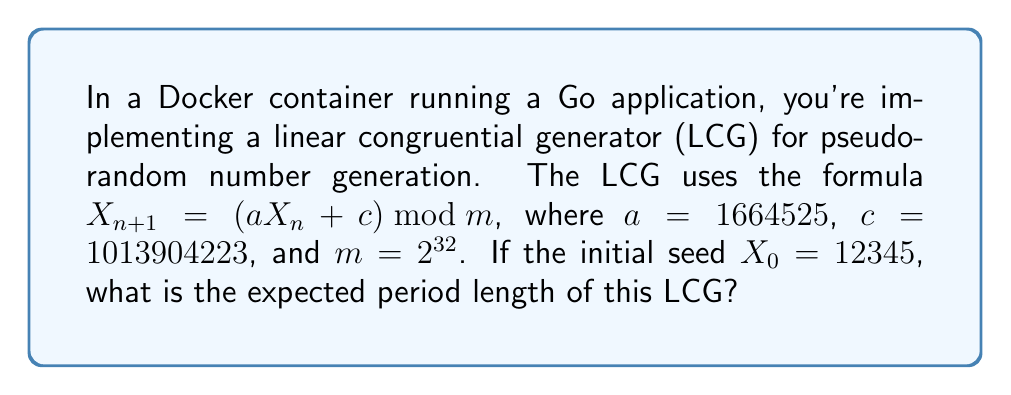Give your solution to this math problem. To determine the expected period length of a linear congruential generator (LCG), we need to analyze its parameters. For an LCG with the formula $X_{n+1} = (aX_n + c) \bmod m$, the period can reach its maximum value of $m$ if and only if:

1. $c$ and $m$ are relatively prime
2. $a-1$ is divisible by all prime factors of $m$
3. $a-1$ is divisible by 4 if $m$ is divisible by 4

Let's check these conditions for our LCG:

1. $c = 1013904223$ and $m = 2^{32} = 4294967296$
   $\gcd(c, m) = \gcd(1013904223, 4294967296) = 1$ (they are relatively prime)

2. $m = 2^{32}$, so the only prime factor is 2
   $a - 1 = 1664525 - 1 = 1664524 = 2^2 \times 416131$
   1664524 is divisible by 2, satisfying this condition

3. $m = 2^{32}$ is divisible by 4
   $a - 1 = 1664524$ is divisible by 4

Since all three conditions are met, this LCG will have the maximum possible period length, which is $m = 2^{32}$.
Answer: $2^{32}$ 